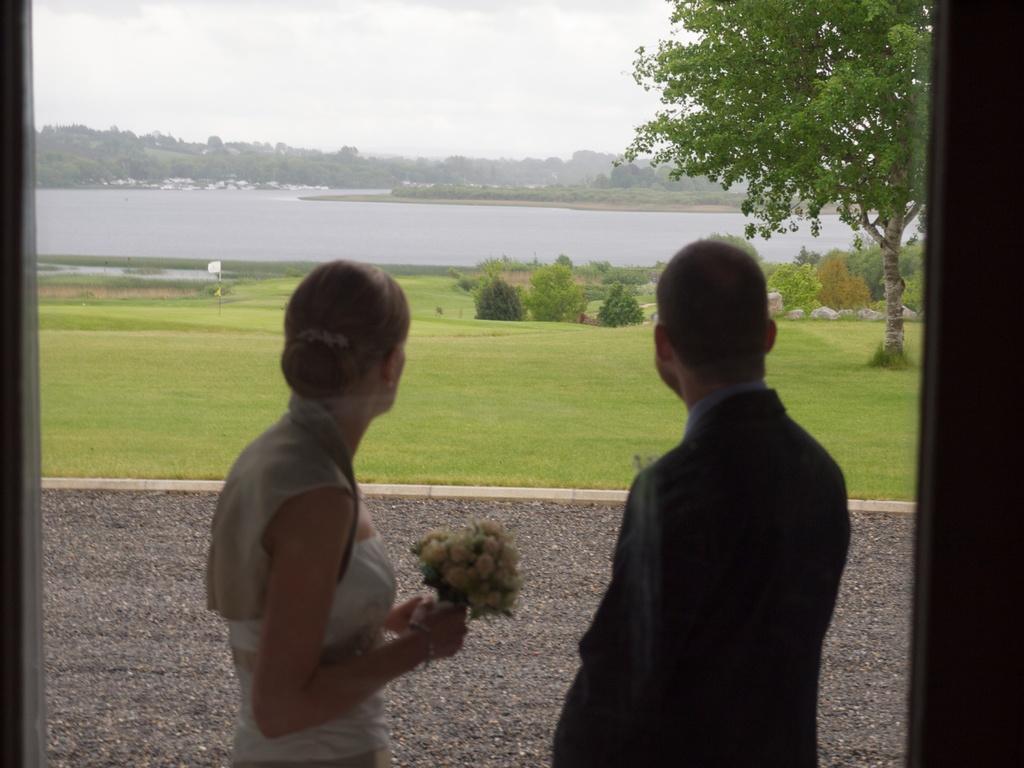In one or two sentences, can you explain what this image depicts? Here I can see a woman and a man standing and looking at the back side. The woman is holding some flowers in the hands. In the background, I can see the grass, plants, trees and sea. At the top of the image I can see the sky. On the right and left side of the image I can see the wooden planks, it seems to be a window glass. 